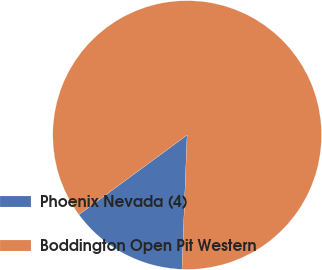Convert chart to OTSL. <chart><loc_0><loc_0><loc_500><loc_500><pie_chart><fcel>Phoenix Nevada (4)<fcel>Boddington Open Pit Western<nl><fcel>14.29%<fcel>85.71%<nl></chart> 